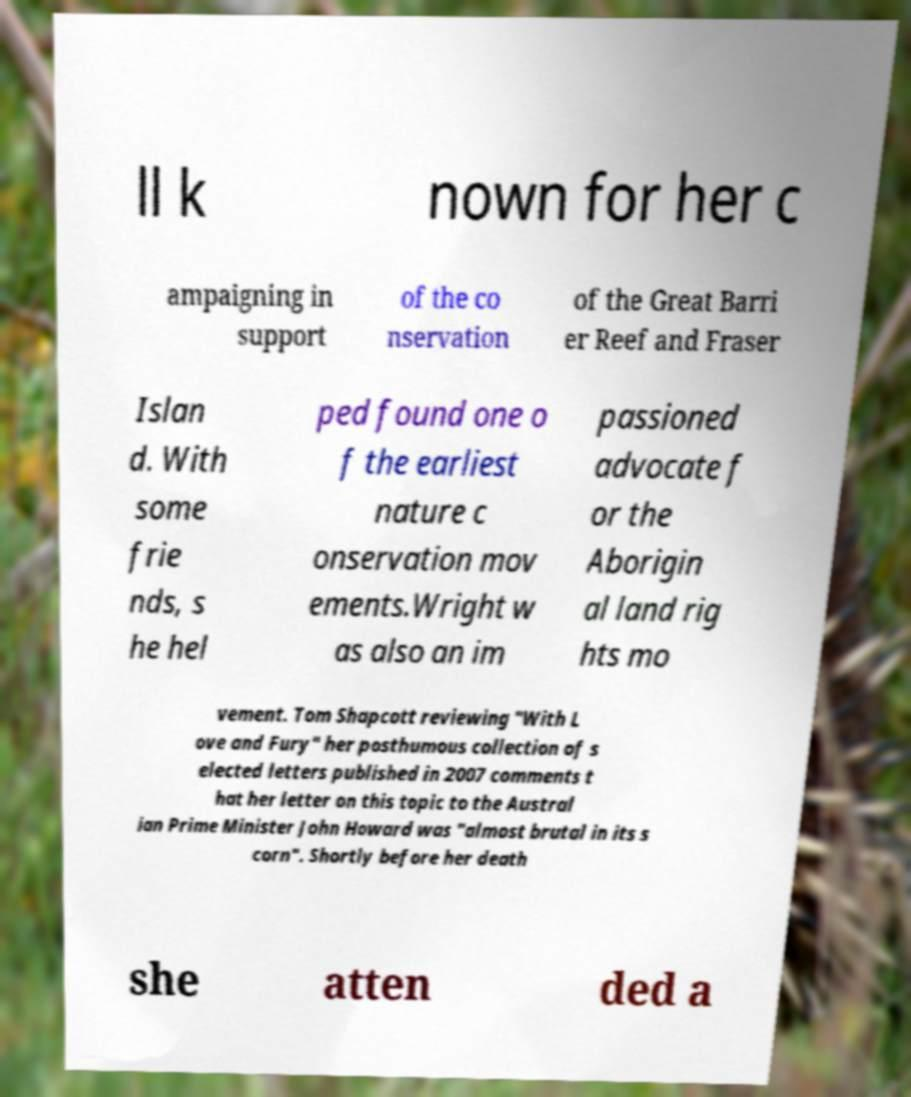Please identify and transcribe the text found in this image. ll k nown for her c ampaigning in support of the co nservation of the Great Barri er Reef and Fraser Islan d. With some frie nds, s he hel ped found one o f the earliest nature c onservation mov ements.Wright w as also an im passioned advocate f or the Aborigin al land rig hts mo vement. Tom Shapcott reviewing "With L ove and Fury" her posthumous collection of s elected letters published in 2007 comments t hat her letter on this topic to the Austral ian Prime Minister John Howard was "almost brutal in its s corn". Shortly before her death she atten ded a 